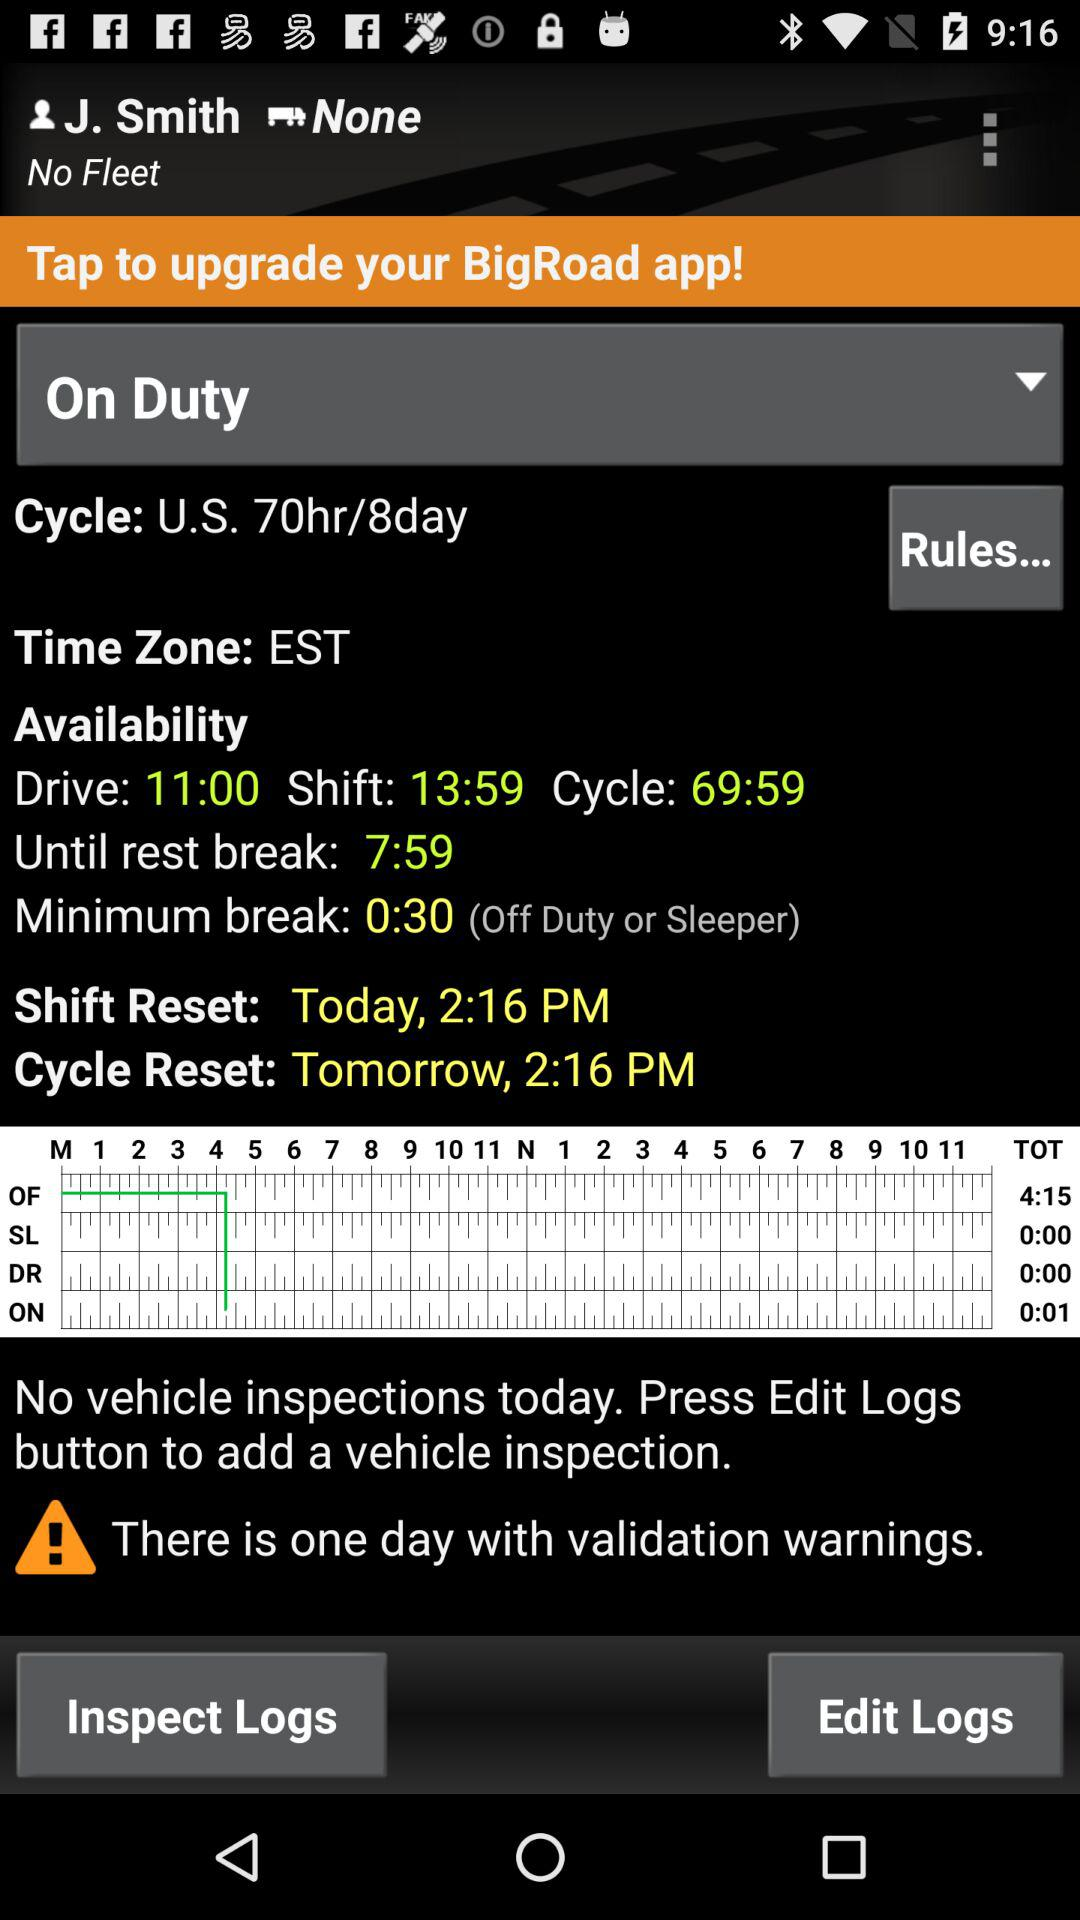What is the duration of the break? The duration of the break is 30 seconds. 